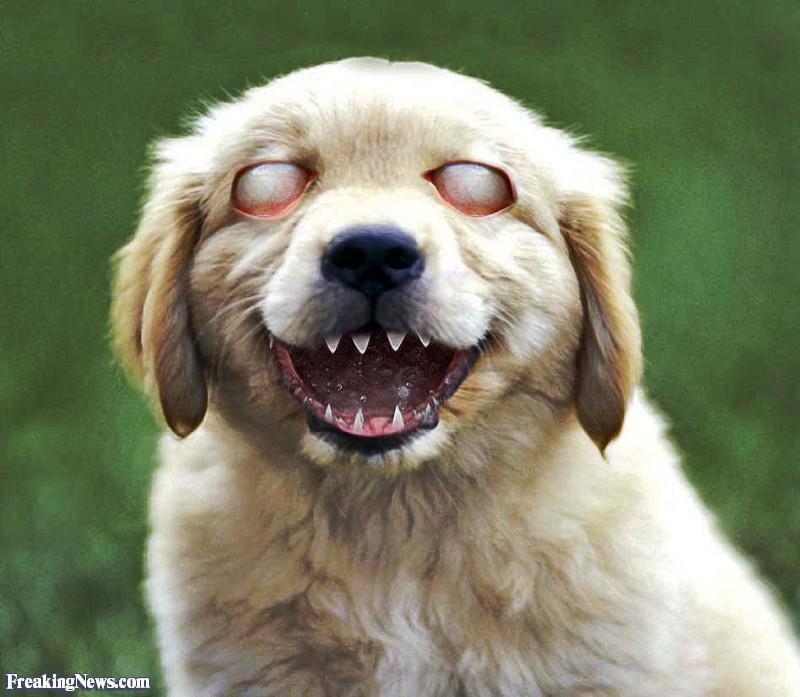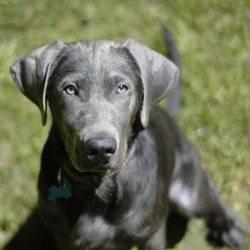The first image is the image on the left, the second image is the image on the right. For the images shown, is this caption "An image shows a blue-eyed gray dog wearing a red collar." true? Answer yes or no. No. The first image is the image on the left, the second image is the image on the right. For the images displayed, is the sentence "Someone is holding one of the dogs." factually correct? Answer yes or no. No. 